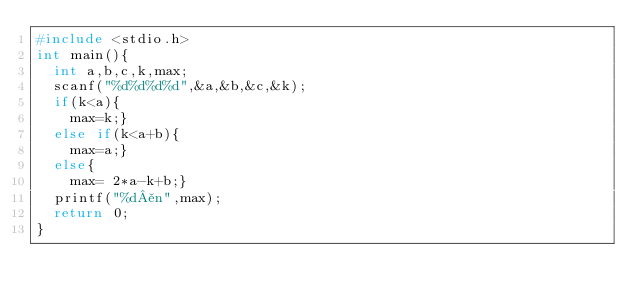<code> <loc_0><loc_0><loc_500><loc_500><_C++_>#include <stdio.h>
int main(){
  int a,b,c,k,max;
  scanf("%d%d%d%d",&a,&b,&c,&k);
  if(k<a){
    max=k;}
  else if(k<a+b){
    max=a;}
  else{
    max= 2*a-k+b;}
  printf("%d¥n",max);
  return 0;
}
     

</code> 